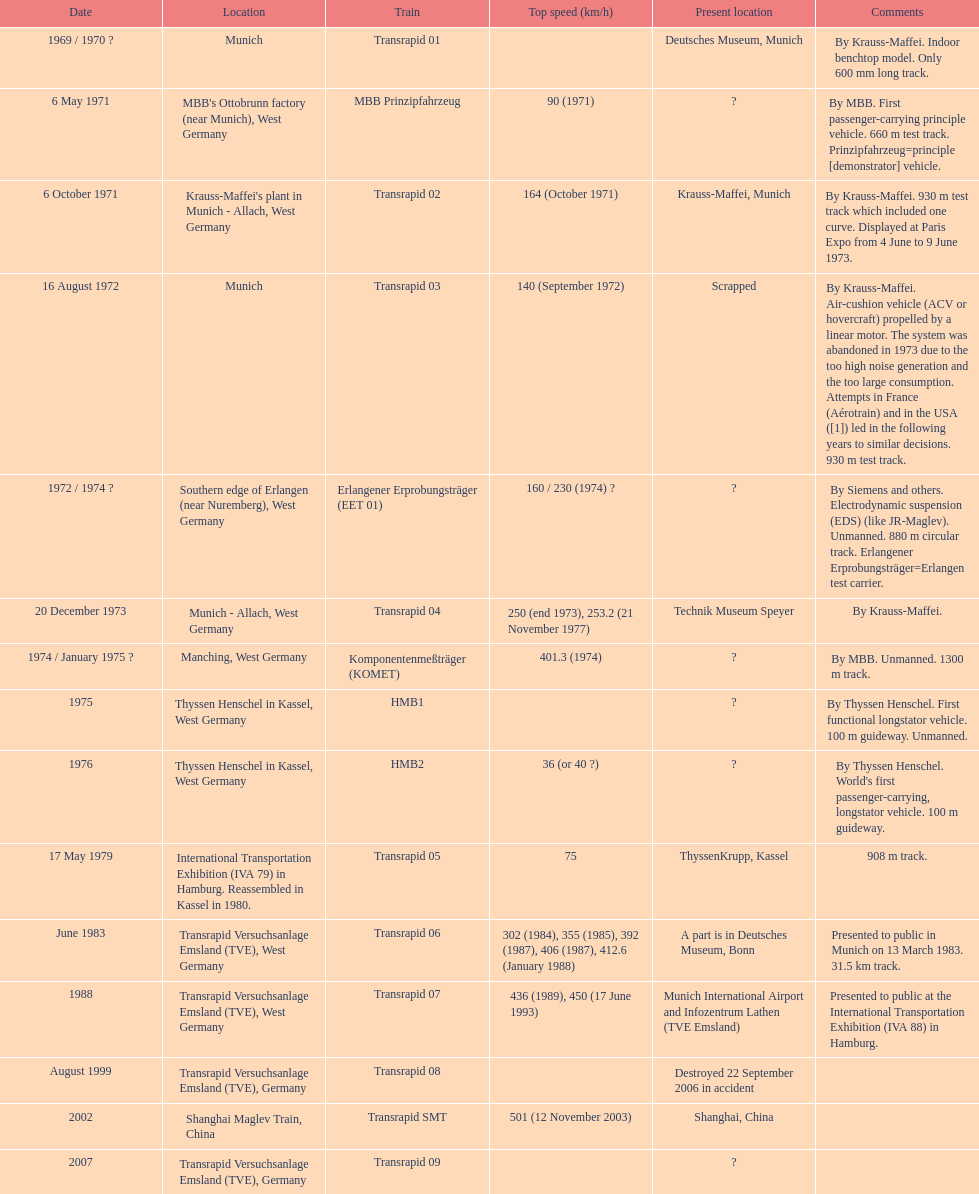How many trains listed have the same speed as the hmb2? 0. 